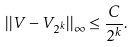Convert formula to latex. <formula><loc_0><loc_0><loc_500><loc_500>| | V - V _ { 2 ^ { k } } | | _ { \infty } \leq \frac { C } { 2 ^ { k } } .</formula> 